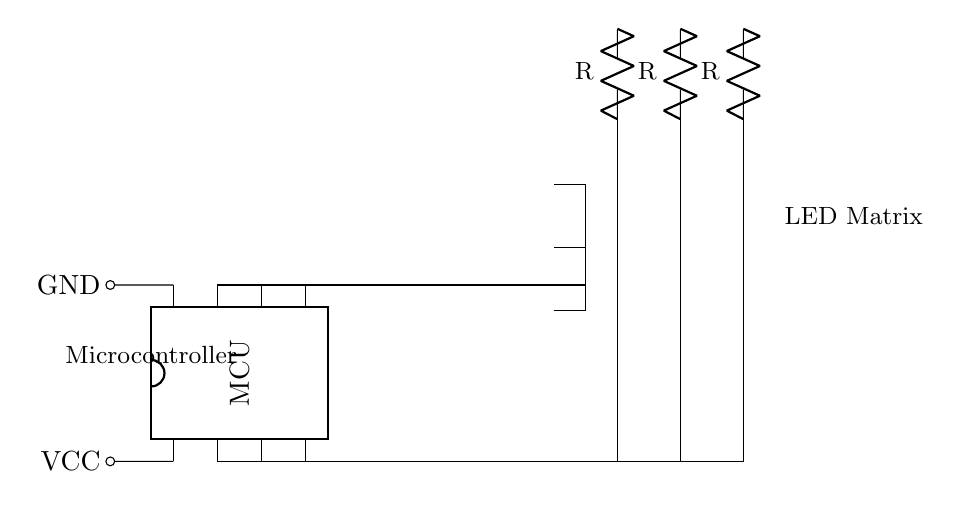What component represents the microcontroller? In the circuit diagram, the microcontroller is represented by the DIP chip icon labeled "MCU" which has connections for power and signal pins.
Answer: MCU How many LED elements are in the LED matrix? The LED matrix consists of a 3x3 arrangement, which results in a total of 9 individual LED elements being displayed in the circuit.
Answer: 9 What is the function of the resistors in this circuit? The resistors are used for current limiting, preventing excess current from flowing through the LEDs which could damage them.
Answer: Current limiting Which pins of the microcontroller are connected to the LED matrix? The pins connected to the LED matrix are pins 2, 3, 4, 5, 6, and 7, as indicated by the connections leading from the microcontroller to the respective LEDs in the matrix.
Answer: Pins 2, 3, 4, 5, 6, 7 What is the orientation of the microcontroller in the diagram? The microcontroller is oriented vertically, with the longer side of the chip parallel to the vertical axis, illustrating the placement of the pins effectively.
Answer: Vertical How does the power supply connect to the microcontroller? The power supply connects to the microcontroller through pin 1 for power (VCC) and pin 8 for ground (GND), ensuring proper operation of the circuit.
Answer: Pin 1 and pin 8 